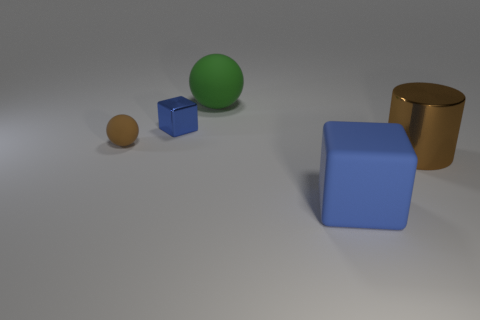The large object that is made of the same material as the green ball is what color?
Offer a very short reply. Blue. There is a metal thing that is the same size as the green rubber object; what is its color?
Your answer should be compact. Brown. How many other things are there of the same size as the brown matte thing?
Offer a very short reply. 1. Is the color of the big rubber block the same as the small metal cube?
Offer a very short reply. Yes. What number of tiny brown rubber spheres are in front of the rubber object that is in front of the rubber sphere left of the green sphere?
Give a very brief answer. 0. Is there any other thing that has the same color as the tiny cube?
Offer a terse response. Yes. There is a blue thing on the left side of the matte block; does it have the same size as the brown cylinder?
Make the answer very short. No. How many rubber balls are in front of the metal block that is left of the large brown object?
Make the answer very short. 1. There is a block that is left of the rubber sphere that is behind the metal block; is there a sphere to the left of it?
Provide a succinct answer. Yes. What is the material of the other object that is the same shape as the green thing?
Ensure brevity in your answer.  Rubber. 